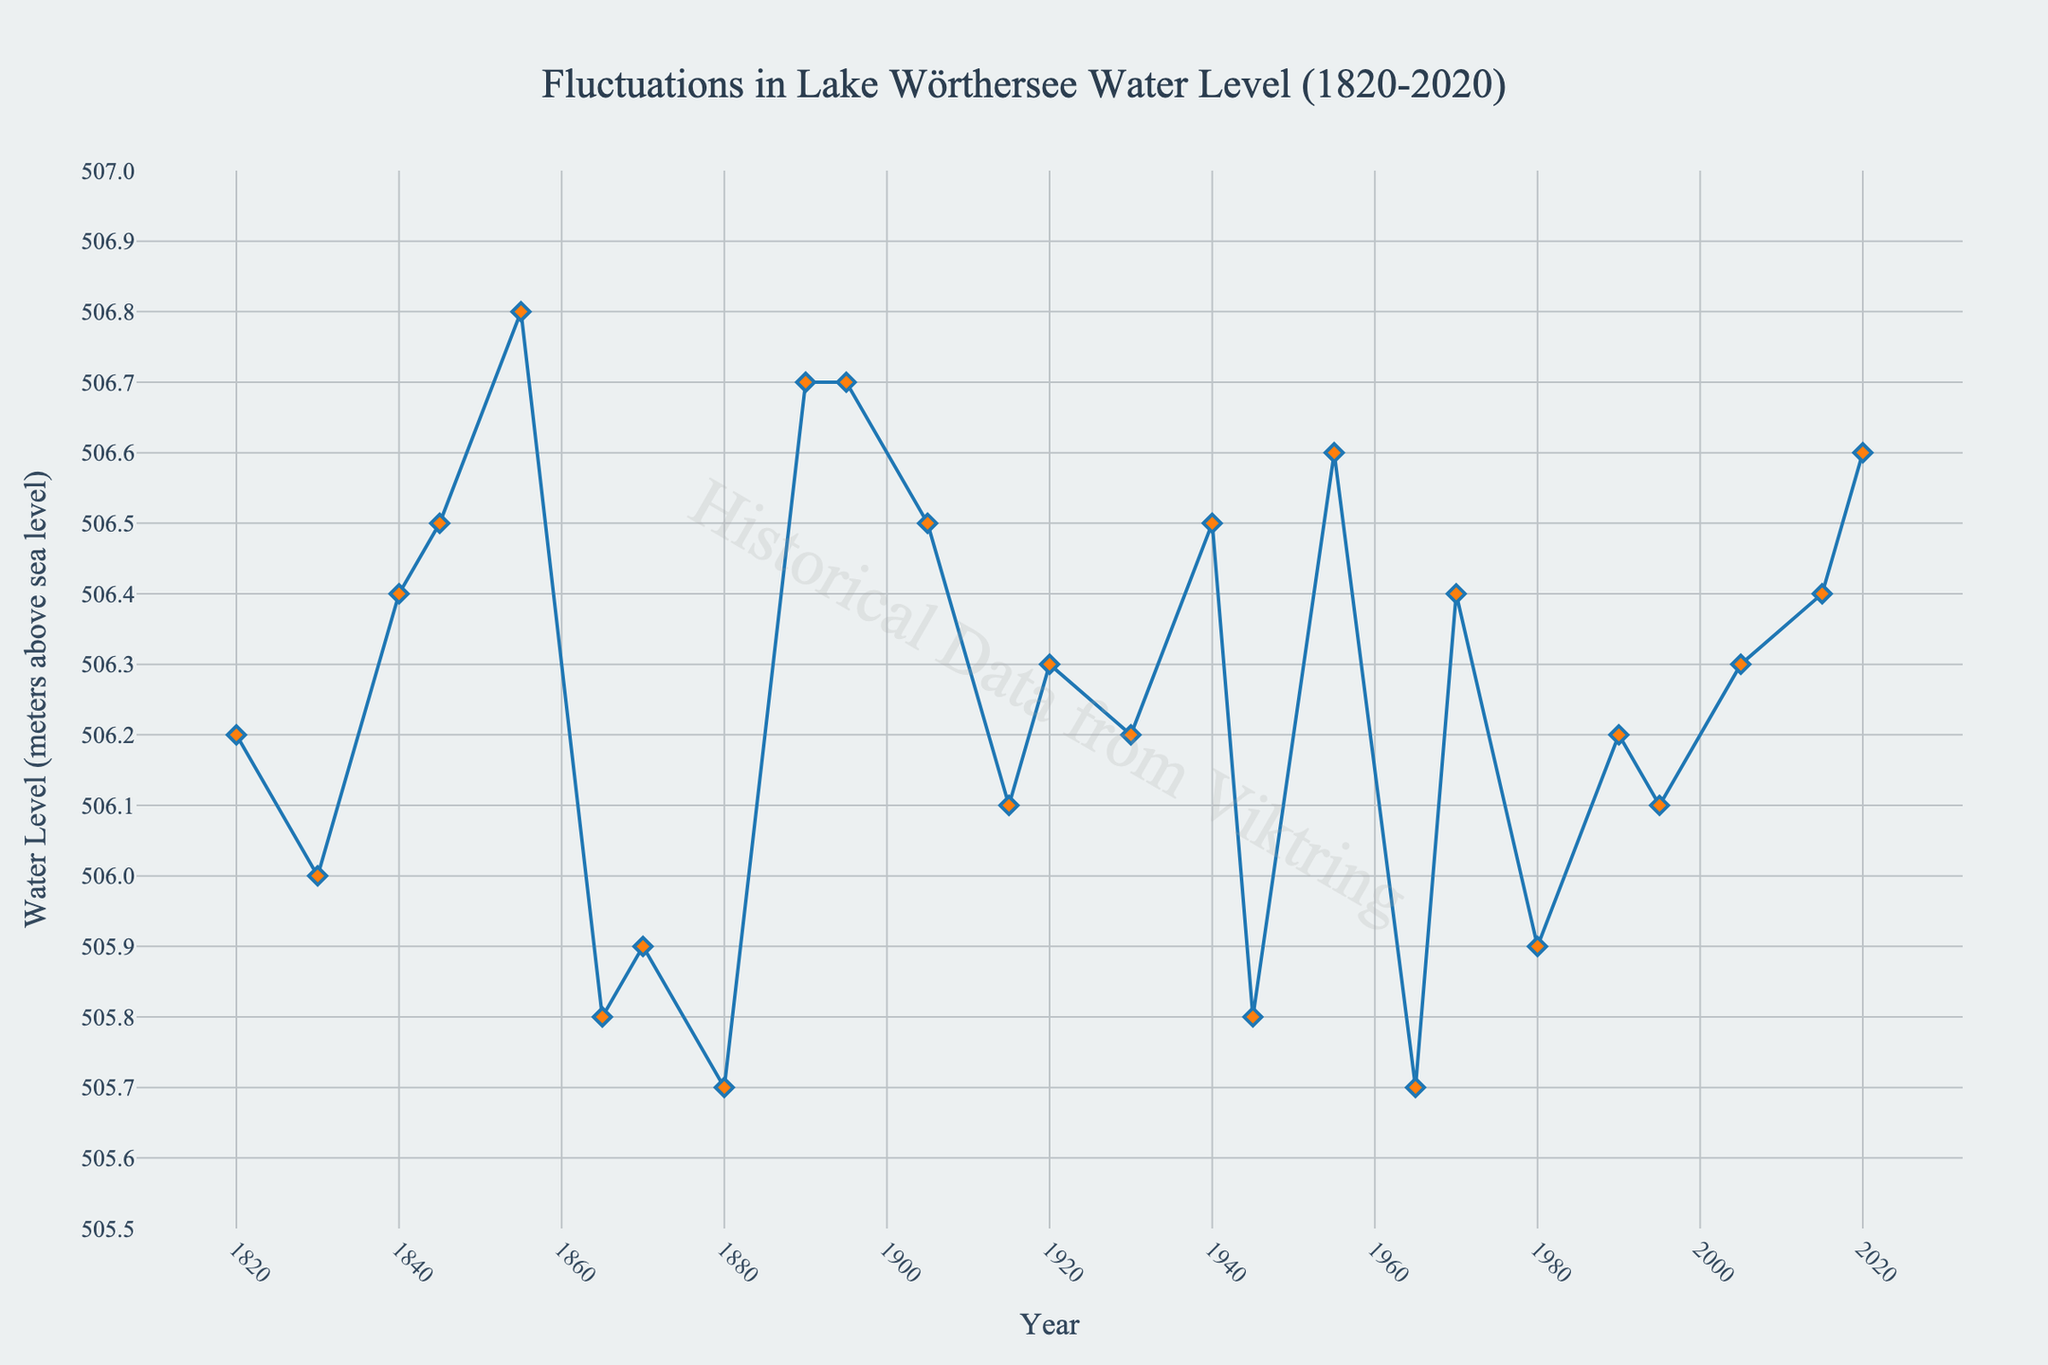What's the highest water level recorded in Lake Wörthersee between 1820 and 2020? Look for the highest point on the line chart. The maximum water level is observed at 506.8 meters above sea level in the years 1855 and 1895.
Answer: 506.8 meters Which year recorded the lowest water level? Identify the lowest point on the line chart. The minimum water level is observed at 505.7 meters above sea level in the years 1880 and 1965.
Answer: 1880 and 1965 How much did the water level change from 1945 to 1970? Note the water level in 1945 (505.8 meters) and 1970 (506.4 meters). Calculate the difference: 506.4 - 505.8 = 0.6 meters.
Answer: 0.6 meters Between which two consecutive data points is the greatest increase in water level observed? Examine the line chart for the steepest upward slope. The largest increase is from 1845 (506.5 meters) to 1855 (506.8 meters), with a difference of 0.3 meters.
Answer: 1845 to 1855 Which decades saw a decrease in water level from the previous recorded data point? Compare each data point with the previous one to observe decreases. The decades with decreases are 1870 from 1845, 1880 from 1855, 1945 from 1920, 1965 from 1940, and 1980 from 1955.
Answer: 1870, 1880, 1945, 1965, 1980 During which decade was the average water level the highest, and what was the value? Calculate the average water level for each decade, then find the highest. The 1850s have an average: (506.4 + 506.8) / 2 = 506.6 meters above sea level.
Answer: 1850s, 506.6 meters What is the general trend of the water level from 1820 to 2020? Analyze the overall pattern in the line chart. The water level fluctuates but shows no clear long-term increasing or decreasing trend, remaining around 506 meters.
Answer: Stable/fluctuating How did the water level change from 1920 to 1940, and then from 1940 to 1965? From 1920 (506.3 meters) to 1940 (506.5 meters), the level increased by 0.2 meters. From 1940 to 1965 (505.7 meters), it decreased by 0.8 meters.
Answer: +0.2 meters, -0.8 meters What was the water level in 2005 and how does it compare to 2020? Check the water level in 2005 (506.3 meters) and compare it to 2020 (506.6 meters). The difference is 506.6 - 506.3 = 0.3 meters, meaning the water level increased.
Answer: 2005: 506.3, increased by 0.3 meters Is there any noticeable periodic fluctuation or pattern in the water level over the 200 years? Observe the peaks and troughs in the line chart to identify any recurring patterns. The chart does not show a clear periodic pattern, but it does show fluctuations every few decades.
Answer: No clear periodic pattern 